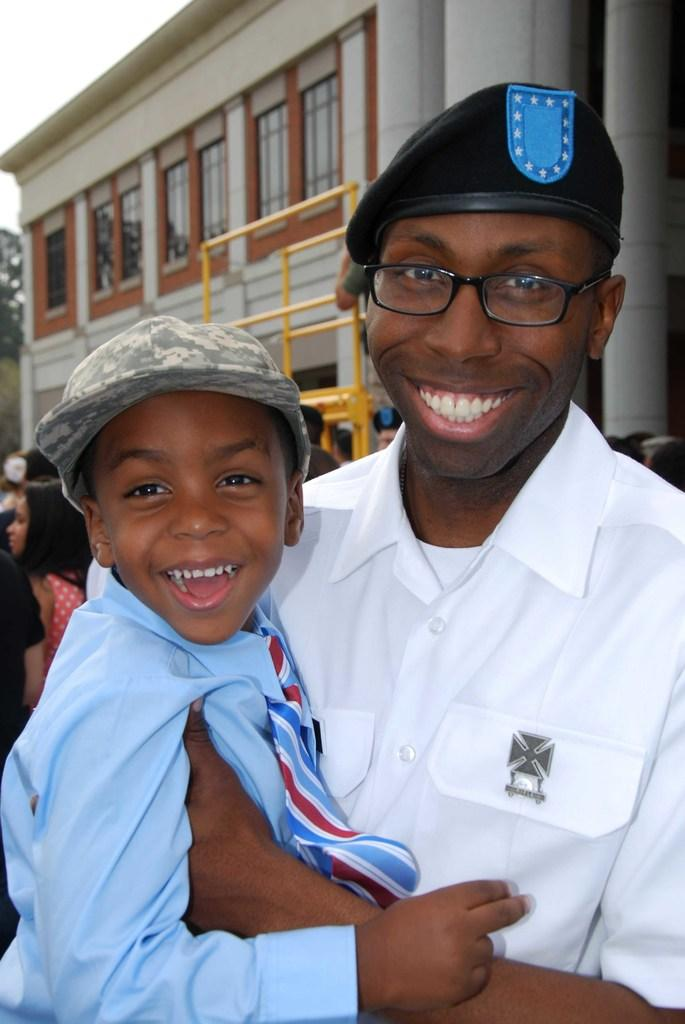What is the main subject of the image? The main subject of the image is a man. What is the man doing in the image? The man is holding a boy with his hand. How are the man and the boy feeling in the image? Both the man and the boy are smiling in the image. What can be seen in the background of the image? There is a building with windows and a group of people in the background of the image. What arithmetic problem is the man solving in the image? There is no indication in the image that the man is solving an arithmetic problem. Is the man a spy in the image? There is no information in the image to suggest that the man is a spy. 